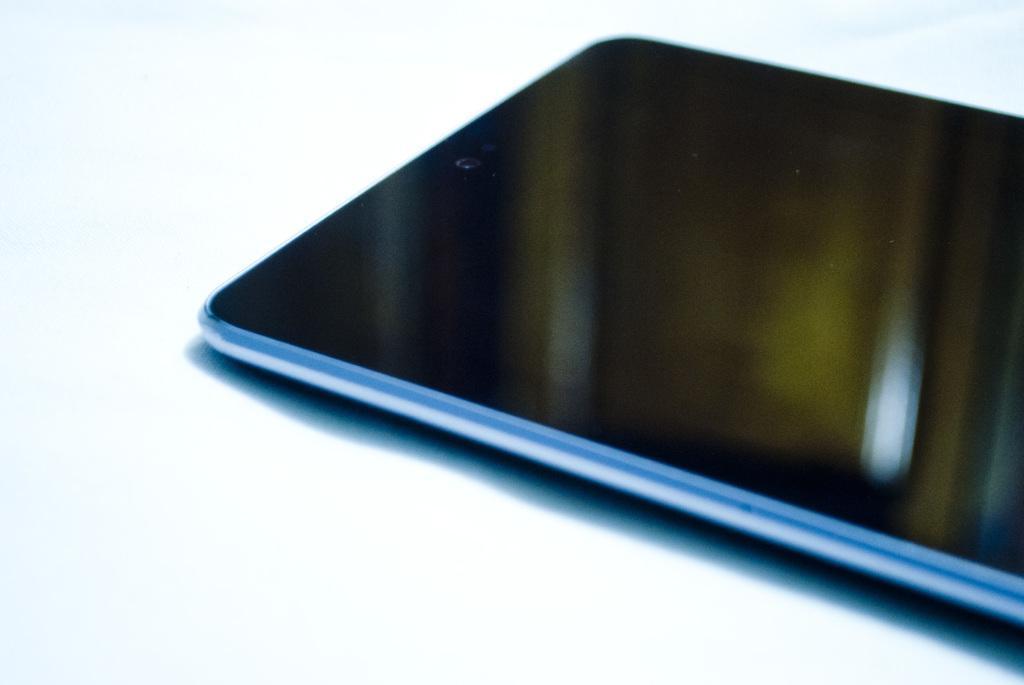Can you describe this image briefly? This image consist of a mobile phone which is in the center. 